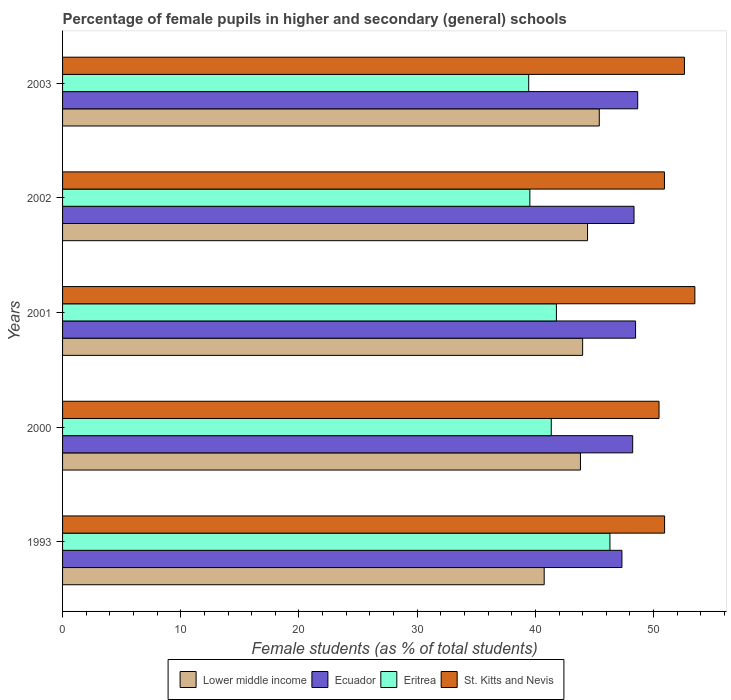How many bars are there on the 5th tick from the bottom?
Ensure brevity in your answer.  4. What is the label of the 4th group of bars from the top?
Provide a succinct answer. 2000. What is the percentage of female pupils in higher and secondary schools in Eritrea in 1993?
Offer a very short reply. 46.31. Across all years, what is the maximum percentage of female pupils in higher and secondary schools in Eritrea?
Give a very brief answer. 46.31. Across all years, what is the minimum percentage of female pupils in higher and secondary schools in Eritrea?
Your answer should be very brief. 39.44. In which year was the percentage of female pupils in higher and secondary schools in Ecuador maximum?
Ensure brevity in your answer.  2003. What is the total percentage of female pupils in higher and secondary schools in Ecuador in the graph?
Your response must be concise. 241.03. What is the difference between the percentage of female pupils in higher and secondary schools in Lower middle income in 2001 and that in 2003?
Keep it short and to the point. -1.41. What is the difference between the percentage of female pupils in higher and secondary schools in Ecuador in 2000 and the percentage of female pupils in higher and secondary schools in Eritrea in 2001?
Provide a succinct answer. 6.45. What is the average percentage of female pupils in higher and secondary schools in Eritrea per year?
Give a very brief answer. 41.68. In the year 1993, what is the difference between the percentage of female pupils in higher and secondary schools in St. Kitts and Nevis and percentage of female pupils in higher and secondary schools in Eritrea?
Your response must be concise. 4.62. In how many years, is the percentage of female pupils in higher and secondary schools in Lower middle income greater than 50 %?
Offer a very short reply. 0. What is the ratio of the percentage of female pupils in higher and secondary schools in Eritrea in 1993 to that in 2000?
Give a very brief answer. 1.12. Is the difference between the percentage of female pupils in higher and secondary schools in St. Kitts and Nevis in 2001 and 2002 greater than the difference between the percentage of female pupils in higher and secondary schools in Eritrea in 2001 and 2002?
Your answer should be very brief. Yes. What is the difference between the highest and the second highest percentage of female pupils in higher and secondary schools in Eritrea?
Provide a succinct answer. 4.53. What is the difference between the highest and the lowest percentage of female pupils in higher and secondary schools in Lower middle income?
Make the answer very short. 4.66. Is the sum of the percentage of female pupils in higher and secondary schools in Lower middle income in 2000 and 2002 greater than the maximum percentage of female pupils in higher and secondary schools in Eritrea across all years?
Your response must be concise. Yes. Is it the case that in every year, the sum of the percentage of female pupils in higher and secondary schools in Eritrea and percentage of female pupils in higher and secondary schools in Ecuador is greater than the sum of percentage of female pupils in higher and secondary schools in St. Kitts and Nevis and percentage of female pupils in higher and secondary schools in Lower middle income?
Provide a succinct answer. Yes. What does the 1st bar from the top in 1993 represents?
Give a very brief answer. St. Kitts and Nevis. What does the 3rd bar from the bottom in 1993 represents?
Give a very brief answer. Eritrea. How many bars are there?
Your answer should be compact. 20. Are all the bars in the graph horizontal?
Your response must be concise. Yes. What is the difference between two consecutive major ticks on the X-axis?
Provide a short and direct response. 10. Does the graph contain any zero values?
Give a very brief answer. No. Does the graph contain grids?
Your answer should be compact. No. Where does the legend appear in the graph?
Provide a succinct answer. Bottom center. How many legend labels are there?
Offer a terse response. 4. How are the legend labels stacked?
Offer a terse response. Horizontal. What is the title of the graph?
Your answer should be compact. Percentage of female pupils in higher and secondary (general) schools. Does "Sint Maarten (Dutch part)" appear as one of the legend labels in the graph?
Make the answer very short. No. What is the label or title of the X-axis?
Offer a very short reply. Female students (as % of total students). What is the label or title of the Y-axis?
Your answer should be very brief. Years. What is the Female students (as % of total students) of Lower middle income in 1993?
Your answer should be compact. 40.74. What is the Female students (as % of total students) in Ecuador in 1993?
Your answer should be very brief. 47.32. What is the Female students (as % of total students) in Eritrea in 1993?
Ensure brevity in your answer.  46.31. What is the Female students (as % of total students) in St. Kitts and Nevis in 1993?
Ensure brevity in your answer.  50.93. What is the Female students (as % of total students) in Lower middle income in 2000?
Offer a terse response. 43.81. What is the Female students (as % of total students) in Ecuador in 2000?
Keep it short and to the point. 48.23. What is the Female students (as % of total students) of Eritrea in 2000?
Give a very brief answer. 41.34. What is the Female students (as % of total students) in St. Kitts and Nevis in 2000?
Provide a succinct answer. 50.46. What is the Female students (as % of total students) in Lower middle income in 2001?
Your answer should be compact. 44. What is the Female students (as % of total students) in Ecuador in 2001?
Your response must be concise. 48.48. What is the Female students (as % of total students) in Eritrea in 2001?
Ensure brevity in your answer.  41.78. What is the Female students (as % of total students) of St. Kitts and Nevis in 2001?
Keep it short and to the point. 53.49. What is the Female students (as % of total students) in Lower middle income in 2002?
Your response must be concise. 44.41. What is the Female students (as % of total students) of Ecuador in 2002?
Your answer should be very brief. 48.35. What is the Female students (as % of total students) in Eritrea in 2002?
Offer a very short reply. 39.53. What is the Female students (as % of total students) of St. Kitts and Nevis in 2002?
Your answer should be compact. 50.92. What is the Female students (as % of total students) of Lower middle income in 2003?
Make the answer very short. 45.41. What is the Female students (as % of total students) of Ecuador in 2003?
Ensure brevity in your answer.  48.66. What is the Female students (as % of total students) of Eritrea in 2003?
Your answer should be very brief. 39.44. What is the Female students (as % of total students) of St. Kitts and Nevis in 2003?
Ensure brevity in your answer.  52.61. Across all years, what is the maximum Female students (as % of total students) in Lower middle income?
Ensure brevity in your answer.  45.41. Across all years, what is the maximum Female students (as % of total students) in Ecuador?
Ensure brevity in your answer.  48.66. Across all years, what is the maximum Female students (as % of total students) in Eritrea?
Your answer should be compact. 46.31. Across all years, what is the maximum Female students (as % of total students) of St. Kitts and Nevis?
Provide a succinct answer. 53.49. Across all years, what is the minimum Female students (as % of total students) of Lower middle income?
Offer a very short reply. 40.74. Across all years, what is the minimum Female students (as % of total students) of Ecuador?
Offer a terse response. 47.32. Across all years, what is the minimum Female students (as % of total students) in Eritrea?
Your answer should be compact. 39.44. Across all years, what is the minimum Female students (as % of total students) in St. Kitts and Nevis?
Your response must be concise. 50.46. What is the total Female students (as % of total students) in Lower middle income in the graph?
Ensure brevity in your answer.  218.38. What is the total Female students (as % of total students) in Ecuador in the graph?
Provide a short and direct response. 241.03. What is the total Female students (as % of total students) in Eritrea in the graph?
Keep it short and to the point. 208.4. What is the total Female students (as % of total students) of St. Kitts and Nevis in the graph?
Give a very brief answer. 258.42. What is the difference between the Female students (as % of total students) of Lower middle income in 1993 and that in 2000?
Offer a very short reply. -3.07. What is the difference between the Female students (as % of total students) in Ecuador in 1993 and that in 2000?
Ensure brevity in your answer.  -0.91. What is the difference between the Female students (as % of total students) of Eritrea in 1993 and that in 2000?
Offer a very short reply. 4.96. What is the difference between the Female students (as % of total students) in St. Kitts and Nevis in 1993 and that in 2000?
Provide a succinct answer. 0.47. What is the difference between the Female students (as % of total students) of Lower middle income in 1993 and that in 2001?
Your answer should be compact. -3.25. What is the difference between the Female students (as % of total students) of Ecuador in 1993 and that in 2001?
Provide a succinct answer. -1.15. What is the difference between the Female students (as % of total students) of Eritrea in 1993 and that in 2001?
Your answer should be compact. 4.53. What is the difference between the Female students (as % of total students) of St. Kitts and Nevis in 1993 and that in 2001?
Provide a short and direct response. -2.56. What is the difference between the Female students (as % of total students) of Lower middle income in 1993 and that in 2002?
Your answer should be compact. -3.67. What is the difference between the Female students (as % of total students) in Ecuador in 1993 and that in 2002?
Your response must be concise. -1.02. What is the difference between the Female students (as % of total students) of Eritrea in 1993 and that in 2002?
Offer a very short reply. 6.77. What is the difference between the Female students (as % of total students) in St. Kitts and Nevis in 1993 and that in 2002?
Make the answer very short. 0.01. What is the difference between the Female students (as % of total students) in Lower middle income in 1993 and that in 2003?
Give a very brief answer. -4.66. What is the difference between the Female students (as % of total students) in Ecuador in 1993 and that in 2003?
Offer a very short reply. -1.33. What is the difference between the Female students (as % of total students) in Eritrea in 1993 and that in 2003?
Ensure brevity in your answer.  6.87. What is the difference between the Female students (as % of total students) of St. Kitts and Nevis in 1993 and that in 2003?
Your response must be concise. -1.68. What is the difference between the Female students (as % of total students) in Lower middle income in 2000 and that in 2001?
Offer a terse response. -0.18. What is the difference between the Female students (as % of total students) of Ecuador in 2000 and that in 2001?
Keep it short and to the point. -0.24. What is the difference between the Female students (as % of total students) of Eritrea in 2000 and that in 2001?
Provide a succinct answer. -0.44. What is the difference between the Female students (as % of total students) in St. Kitts and Nevis in 2000 and that in 2001?
Give a very brief answer. -3.03. What is the difference between the Female students (as % of total students) of Lower middle income in 2000 and that in 2002?
Your answer should be compact. -0.6. What is the difference between the Female students (as % of total students) of Ecuador in 2000 and that in 2002?
Your answer should be very brief. -0.11. What is the difference between the Female students (as % of total students) of Eritrea in 2000 and that in 2002?
Make the answer very short. 1.81. What is the difference between the Female students (as % of total students) of St. Kitts and Nevis in 2000 and that in 2002?
Keep it short and to the point. -0.46. What is the difference between the Female students (as % of total students) in Lower middle income in 2000 and that in 2003?
Keep it short and to the point. -1.59. What is the difference between the Female students (as % of total students) of Ecuador in 2000 and that in 2003?
Offer a terse response. -0.42. What is the difference between the Female students (as % of total students) in Eritrea in 2000 and that in 2003?
Provide a succinct answer. 1.91. What is the difference between the Female students (as % of total students) in St. Kitts and Nevis in 2000 and that in 2003?
Provide a succinct answer. -2.15. What is the difference between the Female students (as % of total students) in Lower middle income in 2001 and that in 2002?
Your answer should be very brief. -0.41. What is the difference between the Female students (as % of total students) in Ecuador in 2001 and that in 2002?
Ensure brevity in your answer.  0.13. What is the difference between the Female students (as % of total students) in Eritrea in 2001 and that in 2002?
Ensure brevity in your answer.  2.25. What is the difference between the Female students (as % of total students) in St. Kitts and Nevis in 2001 and that in 2002?
Ensure brevity in your answer.  2.57. What is the difference between the Female students (as % of total students) of Lower middle income in 2001 and that in 2003?
Your response must be concise. -1.41. What is the difference between the Female students (as % of total students) of Ecuador in 2001 and that in 2003?
Keep it short and to the point. -0.18. What is the difference between the Female students (as % of total students) of Eritrea in 2001 and that in 2003?
Provide a succinct answer. 2.34. What is the difference between the Female students (as % of total students) in St. Kitts and Nevis in 2001 and that in 2003?
Your answer should be very brief. 0.88. What is the difference between the Female students (as % of total students) of Lower middle income in 2002 and that in 2003?
Give a very brief answer. -0.99. What is the difference between the Female students (as % of total students) of Ecuador in 2002 and that in 2003?
Offer a terse response. -0.31. What is the difference between the Female students (as % of total students) in Eritrea in 2002 and that in 2003?
Your answer should be compact. 0.1. What is the difference between the Female students (as % of total students) in St. Kitts and Nevis in 2002 and that in 2003?
Offer a terse response. -1.69. What is the difference between the Female students (as % of total students) of Lower middle income in 1993 and the Female students (as % of total students) of Ecuador in 2000?
Offer a very short reply. -7.49. What is the difference between the Female students (as % of total students) in Lower middle income in 1993 and the Female students (as % of total students) in Eritrea in 2000?
Ensure brevity in your answer.  -0.6. What is the difference between the Female students (as % of total students) in Lower middle income in 1993 and the Female students (as % of total students) in St. Kitts and Nevis in 2000?
Your answer should be very brief. -9.72. What is the difference between the Female students (as % of total students) of Ecuador in 1993 and the Female students (as % of total students) of Eritrea in 2000?
Provide a short and direct response. 5.98. What is the difference between the Female students (as % of total students) in Ecuador in 1993 and the Female students (as % of total students) in St. Kitts and Nevis in 2000?
Provide a succinct answer. -3.14. What is the difference between the Female students (as % of total students) of Eritrea in 1993 and the Female students (as % of total students) of St. Kitts and Nevis in 2000?
Offer a very short reply. -4.15. What is the difference between the Female students (as % of total students) of Lower middle income in 1993 and the Female students (as % of total students) of Ecuador in 2001?
Provide a succinct answer. -7.73. What is the difference between the Female students (as % of total students) of Lower middle income in 1993 and the Female students (as % of total students) of Eritrea in 2001?
Your response must be concise. -1.03. What is the difference between the Female students (as % of total students) of Lower middle income in 1993 and the Female students (as % of total students) of St. Kitts and Nevis in 2001?
Offer a very short reply. -12.75. What is the difference between the Female students (as % of total students) in Ecuador in 1993 and the Female students (as % of total students) in Eritrea in 2001?
Ensure brevity in your answer.  5.54. What is the difference between the Female students (as % of total students) in Ecuador in 1993 and the Female students (as % of total students) in St. Kitts and Nevis in 2001?
Provide a succinct answer. -6.17. What is the difference between the Female students (as % of total students) of Eritrea in 1993 and the Female students (as % of total students) of St. Kitts and Nevis in 2001?
Ensure brevity in your answer.  -7.19. What is the difference between the Female students (as % of total students) in Lower middle income in 1993 and the Female students (as % of total students) in Ecuador in 2002?
Provide a short and direct response. -7.6. What is the difference between the Female students (as % of total students) in Lower middle income in 1993 and the Female students (as % of total students) in Eritrea in 2002?
Give a very brief answer. 1.21. What is the difference between the Female students (as % of total students) in Lower middle income in 1993 and the Female students (as % of total students) in St. Kitts and Nevis in 2002?
Ensure brevity in your answer.  -10.18. What is the difference between the Female students (as % of total students) in Ecuador in 1993 and the Female students (as % of total students) in Eritrea in 2002?
Keep it short and to the point. 7.79. What is the difference between the Female students (as % of total students) of Ecuador in 1993 and the Female students (as % of total students) of St. Kitts and Nevis in 2002?
Ensure brevity in your answer.  -3.6. What is the difference between the Female students (as % of total students) of Eritrea in 1993 and the Female students (as % of total students) of St. Kitts and Nevis in 2002?
Ensure brevity in your answer.  -4.61. What is the difference between the Female students (as % of total students) in Lower middle income in 1993 and the Female students (as % of total students) in Ecuador in 2003?
Offer a terse response. -7.91. What is the difference between the Female students (as % of total students) in Lower middle income in 1993 and the Female students (as % of total students) in Eritrea in 2003?
Your answer should be very brief. 1.31. What is the difference between the Female students (as % of total students) of Lower middle income in 1993 and the Female students (as % of total students) of St. Kitts and Nevis in 2003?
Provide a succinct answer. -11.87. What is the difference between the Female students (as % of total students) of Ecuador in 1993 and the Female students (as % of total students) of Eritrea in 2003?
Your response must be concise. 7.89. What is the difference between the Female students (as % of total students) of Ecuador in 1993 and the Female students (as % of total students) of St. Kitts and Nevis in 2003?
Ensure brevity in your answer.  -5.29. What is the difference between the Female students (as % of total students) in Eritrea in 1993 and the Female students (as % of total students) in St. Kitts and Nevis in 2003?
Offer a terse response. -6.3. What is the difference between the Female students (as % of total students) of Lower middle income in 2000 and the Female students (as % of total students) of Ecuador in 2001?
Offer a terse response. -4.66. What is the difference between the Female students (as % of total students) in Lower middle income in 2000 and the Female students (as % of total students) in Eritrea in 2001?
Offer a terse response. 2.03. What is the difference between the Female students (as % of total students) in Lower middle income in 2000 and the Female students (as % of total students) in St. Kitts and Nevis in 2001?
Your answer should be very brief. -9.68. What is the difference between the Female students (as % of total students) of Ecuador in 2000 and the Female students (as % of total students) of Eritrea in 2001?
Ensure brevity in your answer.  6.45. What is the difference between the Female students (as % of total students) of Ecuador in 2000 and the Female students (as % of total students) of St. Kitts and Nevis in 2001?
Keep it short and to the point. -5.26. What is the difference between the Female students (as % of total students) of Eritrea in 2000 and the Female students (as % of total students) of St. Kitts and Nevis in 2001?
Keep it short and to the point. -12.15. What is the difference between the Female students (as % of total students) in Lower middle income in 2000 and the Female students (as % of total students) in Ecuador in 2002?
Your response must be concise. -4.53. What is the difference between the Female students (as % of total students) of Lower middle income in 2000 and the Female students (as % of total students) of Eritrea in 2002?
Provide a succinct answer. 4.28. What is the difference between the Female students (as % of total students) of Lower middle income in 2000 and the Female students (as % of total students) of St. Kitts and Nevis in 2002?
Offer a terse response. -7.11. What is the difference between the Female students (as % of total students) of Ecuador in 2000 and the Female students (as % of total students) of Eritrea in 2002?
Ensure brevity in your answer.  8.7. What is the difference between the Female students (as % of total students) of Ecuador in 2000 and the Female students (as % of total students) of St. Kitts and Nevis in 2002?
Offer a very short reply. -2.69. What is the difference between the Female students (as % of total students) in Eritrea in 2000 and the Female students (as % of total students) in St. Kitts and Nevis in 2002?
Offer a very short reply. -9.58. What is the difference between the Female students (as % of total students) of Lower middle income in 2000 and the Female students (as % of total students) of Ecuador in 2003?
Provide a short and direct response. -4.84. What is the difference between the Female students (as % of total students) of Lower middle income in 2000 and the Female students (as % of total students) of Eritrea in 2003?
Make the answer very short. 4.38. What is the difference between the Female students (as % of total students) in Lower middle income in 2000 and the Female students (as % of total students) in St. Kitts and Nevis in 2003?
Ensure brevity in your answer.  -8.8. What is the difference between the Female students (as % of total students) of Ecuador in 2000 and the Female students (as % of total students) of Eritrea in 2003?
Offer a terse response. 8.8. What is the difference between the Female students (as % of total students) of Ecuador in 2000 and the Female students (as % of total students) of St. Kitts and Nevis in 2003?
Provide a short and direct response. -4.38. What is the difference between the Female students (as % of total students) of Eritrea in 2000 and the Female students (as % of total students) of St. Kitts and Nevis in 2003?
Your answer should be very brief. -11.27. What is the difference between the Female students (as % of total students) in Lower middle income in 2001 and the Female students (as % of total students) in Ecuador in 2002?
Keep it short and to the point. -4.35. What is the difference between the Female students (as % of total students) in Lower middle income in 2001 and the Female students (as % of total students) in Eritrea in 2002?
Keep it short and to the point. 4.46. What is the difference between the Female students (as % of total students) in Lower middle income in 2001 and the Female students (as % of total students) in St. Kitts and Nevis in 2002?
Offer a very short reply. -6.92. What is the difference between the Female students (as % of total students) of Ecuador in 2001 and the Female students (as % of total students) of Eritrea in 2002?
Provide a succinct answer. 8.94. What is the difference between the Female students (as % of total students) of Ecuador in 2001 and the Female students (as % of total students) of St. Kitts and Nevis in 2002?
Your answer should be very brief. -2.44. What is the difference between the Female students (as % of total students) in Eritrea in 2001 and the Female students (as % of total students) in St. Kitts and Nevis in 2002?
Your answer should be compact. -9.14. What is the difference between the Female students (as % of total students) in Lower middle income in 2001 and the Female students (as % of total students) in Ecuador in 2003?
Give a very brief answer. -4.66. What is the difference between the Female students (as % of total students) of Lower middle income in 2001 and the Female students (as % of total students) of Eritrea in 2003?
Make the answer very short. 4.56. What is the difference between the Female students (as % of total students) of Lower middle income in 2001 and the Female students (as % of total students) of St. Kitts and Nevis in 2003?
Offer a very short reply. -8.61. What is the difference between the Female students (as % of total students) of Ecuador in 2001 and the Female students (as % of total students) of Eritrea in 2003?
Offer a very short reply. 9.04. What is the difference between the Female students (as % of total students) in Ecuador in 2001 and the Female students (as % of total students) in St. Kitts and Nevis in 2003?
Provide a short and direct response. -4.13. What is the difference between the Female students (as % of total students) of Eritrea in 2001 and the Female students (as % of total students) of St. Kitts and Nevis in 2003?
Keep it short and to the point. -10.83. What is the difference between the Female students (as % of total students) of Lower middle income in 2002 and the Female students (as % of total students) of Ecuador in 2003?
Keep it short and to the point. -4.24. What is the difference between the Female students (as % of total students) of Lower middle income in 2002 and the Female students (as % of total students) of Eritrea in 2003?
Make the answer very short. 4.98. What is the difference between the Female students (as % of total students) in Lower middle income in 2002 and the Female students (as % of total students) in St. Kitts and Nevis in 2003?
Your answer should be very brief. -8.2. What is the difference between the Female students (as % of total students) in Ecuador in 2002 and the Female students (as % of total students) in Eritrea in 2003?
Your response must be concise. 8.91. What is the difference between the Female students (as % of total students) of Ecuador in 2002 and the Female students (as % of total students) of St. Kitts and Nevis in 2003?
Make the answer very short. -4.27. What is the difference between the Female students (as % of total students) in Eritrea in 2002 and the Female students (as % of total students) in St. Kitts and Nevis in 2003?
Make the answer very short. -13.08. What is the average Female students (as % of total students) in Lower middle income per year?
Ensure brevity in your answer.  43.68. What is the average Female students (as % of total students) of Ecuador per year?
Give a very brief answer. 48.21. What is the average Female students (as % of total students) in Eritrea per year?
Offer a very short reply. 41.68. What is the average Female students (as % of total students) of St. Kitts and Nevis per year?
Keep it short and to the point. 51.68. In the year 1993, what is the difference between the Female students (as % of total students) in Lower middle income and Female students (as % of total students) in Ecuador?
Offer a very short reply. -6.58. In the year 1993, what is the difference between the Female students (as % of total students) of Lower middle income and Female students (as % of total students) of Eritrea?
Make the answer very short. -5.56. In the year 1993, what is the difference between the Female students (as % of total students) of Lower middle income and Female students (as % of total students) of St. Kitts and Nevis?
Offer a very short reply. -10.19. In the year 1993, what is the difference between the Female students (as % of total students) of Ecuador and Female students (as % of total students) of Eritrea?
Make the answer very short. 1.01. In the year 1993, what is the difference between the Female students (as % of total students) in Ecuador and Female students (as % of total students) in St. Kitts and Nevis?
Make the answer very short. -3.61. In the year 1993, what is the difference between the Female students (as % of total students) of Eritrea and Female students (as % of total students) of St. Kitts and Nevis?
Make the answer very short. -4.62. In the year 2000, what is the difference between the Female students (as % of total students) in Lower middle income and Female students (as % of total students) in Ecuador?
Make the answer very short. -4.42. In the year 2000, what is the difference between the Female students (as % of total students) of Lower middle income and Female students (as % of total students) of Eritrea?
Offer a terse response. 2.47. In the year 2000, what is the difference between the Female students (as % of total students) of Lower middle income and Female students (as % of total students) of St. Kitts and Nevis?
Your answer should be very brief. -6.65. In the year 2000, what is the difference between the Female students (as % of total students) in Ecuador and Female students (as % of total students) in Eritrea?
Make the answer very short. 6.89. In the year 2000, what is the difference between the Female students (as % of total students) of Ecuador and Female students (as % of total students) of St. Kitts and Nevis?
Your answer should be compact. -2.23. In the year 2000, what is the difference between the Female students (as % of total students) in Eritrea and Female students (as % of total students) in St. Kitts and Nevis?
Make the answer very short. -9.12. In the year 2001, what is the difference between the Female students (as % of total students) in Lower middle income and Female students (as % of total students) in Ecuador?
Your answer should be compact. -4.48. In the year 2001, what is the difference between the Female students (as % of total students) of Lower middle income and Female students (as % of total students) of Eritrea?
Your answer should be very brief. 2.22. In the year 2001, what is the difference between the Female students (as % of total students) of Lower middle income and Female students (as % of total students) of St. Kitts and Nevis?
Your response must be concise. -9.5. In the year 2001, what is the difference between the Female students (as % of total students) of Ecuador and Female students (as % of total students) of Eritrea?
Keep it short and to the point. 6.7. In the year 2001, what is the difference between the Female students (as % of total students) in Ecuador and Female students (as % of total students) in St. Kitts and Nevis?
Your answer should be very brief. -5.02. In the year 2001, what is the difference between the Female students (as % of total students) in Eritrea and Female students (as % of total students) in St. Kitts and Nevis?
Offer a terse response. -11.71. In the year 2002, what is the difference between the Female students (as % of total students) of Lower middle income and Female students (as % of total students) of Ecuador?
Ensure brevity in your answer.  -3.93. In the year 2002, what is the difference between the Female students (as % of total students) of Lower middle income and Female students (as % of total students) of Eritrea?
Provide a short and direct response. 4.88. In the year 2002, what is the difference between the Female students (as % of total students) of Lower middle income and Female students (as % of total students) of St. Kitts and Nevis?
Give a very brief answer. -6.51. In the year 2002, what is the difference between the Female students (as % of total students) of Ecuador and Female students (as % of total students) of Eritrea?
Make the answer very short. 8.81. In the year 2002, what is the difference between the Female students (as % of total students) of Ecuador and Female students (as % of total students) of St. Kitts and Nevis?
Your answer should be compact. -2.57. In the year 2002, what is the difference between the Female students (as % of total students) of Eritrea and Female students (as % of total students) of St. Kitts and Nevis?
Ensure brevity in your answer.  -11.39. In the year 2003, what is the difference between the Female students (as % of total students) in Lower middle income and Female students (as % of total students) in Ecuador?
Make the answer very short. -3.25. In the year 2003, what is the difference between the Female students (as % of total students) in Lower middle income and Female students (as % of total students) in Eritrea?
Ensure brevity in your answer.  5.97. In the year 2003, what is the difference between the Female students (as % of total students) in Lower middle income and Female students (as % of total students) in St. Kitts and Nevis?
Your answer should be very brief. -7.21. In the year 2003, what is the difference between the Female students (as % of total students) of Ecuador and Female students (as % of total students) of Eritrea?
Provide a succinct answer. 9.22. In the year 2003, what is the difference between the Female students (as % of total students) in Ecuador and Female students (as % of total students) in St. Kitts and Nevis?
Provide a succinct answer. -3.95. In the year 2003, what is the difference between the Female students (as % of total students) in Eritrea and Female students (as % of total students) in St. Kitts and Nevis?
Keep it short and to the point. -13.18. What is the ratio of the Female students (as % of total students) in Lower middle income in 1993 to that in 2000?
Provide a succinct answer. 0.93. What is the ratio of the Female students (as % of total students) in Ecuador in 1993 to that in 2000?
Make the answer very short. 0.98. What is the ratio of the Female students (as % of total students) of Eritrea in 1993 to that in 2000?
Give a very brief answer. 1.12. What is the ratio of the Female students (as % of total students) in St. Kitts and Nevis in 1993 to that in 2000?
Your response must be concise. 1.01. What is the ratio of the Female students (as % of total students) in Lower middle income in 1993 to that in 2001?
Make the answer very short. 0.93. What is the ratio of the Female students (as % of total students) of Ecuador in 1993 to that in 2001?
Your response must be concise. 0.98. What is the ratio of the Female students (as % of total students) in Eritrea in 1993 to that in 2001?
Offer a terse response. 1.11. What is the ratio of the Female students (as % of total students) in St. Kitts and Nevis in 1993 to that in 2001?
Your response must be concise. 0.95. What is the ratio of the Female students (as % of total students) in Lower middle income in 1993 to that in 2002?
Keep it short and to the point. 0.92. What is the ratio of the Female students (as % of total students) in Ecuador in 1993 to that in 2002?
Keep it short and to the point. 0.98. What is the ratio of the Female students (as % of total students) in Eritrea in 1993 to that in 2002?
Provide a short and direct response. 1.17. What is the ratio of the Female students (as % of total students) of Lower middle income in 1993 to that in 2003?
Offer a very short reply. 0.9. What is the ratio of the Female students (as % of total students) of Ecuador in 1993 to that in 2003?
Ensure brevity in your answer.  0.97. What is the ratio of the Female students (as % of total students) of Eritrea in 1993 to that in 2003?
Your answer should be compact. 1.17. What is the ratio of the Female students (as % of total students) in St. Kitts and Nevis in 1993 to that in 2003?
Make the answer very short. 0.97. What is the ratio of the Female students (as % of total students) of Lower middle income in 2000 to that in 2001?
Your answer should be very brief. 1. What is the ratio of the Female students (as % of total students) in Ecuador in 2000 to that in 2001?
Keep it short and to the point. 0.99. What is the ratio of the Female students (as % of total students) in St. Kitts and Nevis in 2000 to that in 2001?
Offer a very short reply. 0.94. What is the ratio of the Female students (as % of total students) in Lower middle income in 2000 to that in 2002?
Your response must be concise. 0.99. What is the ratio of the Female students (as % of total students) in Ecuador in 2000 to that in 2002?
Give a very brief answer. 1. What is the ratio of the Female students (as % of total students) in Eritrea in 2000 to that in 2002?
Give a very brief answer. 1.05. What is the ratio of the Female students (as % of total students) of St. Kitts and Nevis in 2000 to that in 2002?
Your answer should be compact. 0.99. What is the ratio of the Female students (as % of total students) in Lower middle income in 2000 to that in 2003?
Provide a short and direct response. 0.96. What is the ratio of the Female students (as % of total students) in Ecuador in 2000 to that in 2003?
Keep it short and to the point. 0.99. What is the ratio of the Female students (as % of total students) in Eritrea in 2000 to that in 2003?
Your answer should be compact. 1.05. What is the ratio of the Female students (as % of total students) of St. Kitts and Nevis in 2000 to that in 2003?
Make the answer very short. 0.96. What is the ratio of the Female students (as % of total students) of Eritrea in 2001 to that in 2002?
Your answer should be compact. 1.06. What is the ratio of the Female students (as % of total students) of St. Kitts and Nevis in 2001 to that in 2002?
Offer a terse response. 1.05. What is the ratio of the Female students (as % of total students) in Lower middle income in 2001 to that in 2003?
Keep it short and to the point. 0.97. What is the ratio of the Female students (as % of total students) of Ecuador in 2001 to that in 2003?
Keep it short and to the point. 1. What is the ratio of the Female students (as % of total students) in Eritrea in 2001 to that in 2003?
Your answer should be compact. 1.06. What is the ratio of the Female students (as % of total students) in St. Kitts and Nevis in 2001 to that in 2003?
Your response must be concise. 1.02. What is the ratio of the Female students (as % of total students) of Lower middle income in 2002 to that in 2003?
Your answer should be very brief. 0.98. What is the ratio of the Female students (as % of total students) in Ecuador in 2002 to that in 2003?
Make the answer very short. 0.99. What is the ratio of the Female students (as % of total students) in Eritrea in 2002 to that in 2003?
Your answer should be compact. 1. What is the ratio of the Female students (as % of total students) of St. Kitts and Nevis in 2002 to that in 2003?
Your answer should be very brief. 0.97. What is the difference between the highest and the second highest Female students (as % of total students) of Lower middle income?
Offer a terse response. 0.99. What is the difference between the highest and the second highest Female students (as % of total students) in Ecuador?
Your answer should be very brief. 0.18. What is the difference between the highest and the second highest Female students (as % of total students) in Eritrea?
Provide a short and direct response. 4.53. What is the difference between the highest and the second highest Female students (as % of total students) in St. Kitts and Nevis?
Provide a succinct answer. 0.88. What is the difference between the highest and the lowest Female students (as % of total students) of Lower middle income?
Give a very brief answer. 4.66. What is the difference between the highest and the lowest Female students (as % of total students) of Ecuador?
Provide a short and direct response. 1.33. What is the difference between the highest and the lowest Female students (as % of total students) of Eritrea?
Ensure brevity in your answer.  6.87. What is the difference between the highest and the lowest Female students (as % of total students) in St. Kitts and Nevis?
Ensure brevity in your answer.  3.03. 